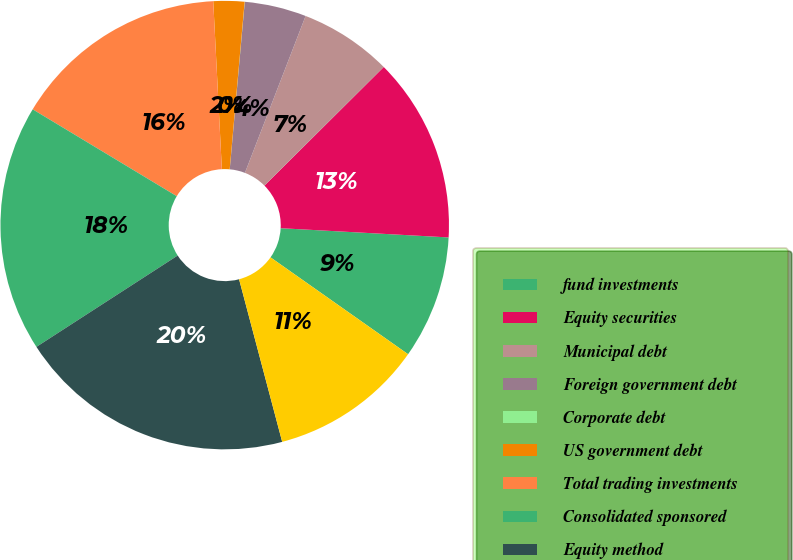Convert chart to OTSL. <chart><loc_0><loc_0><loc_500><loc_500><pie_chart><fcel>fund investments<fcel>Equity securities<fcel>Municipal debt<fcel>Foreign government debt<fcel>Corporate debt<fcel>US government debt<fcel>Total trading investments<fcel>Consolidated sponsored<fcel>Equity method<fcel>Deferred compensation plan<nl><fcel>8.89%<fcel>13.33%<fcel>6.67%<fcel>4.45%<fcel>0.01%<fcel>2.23%<fcel>15.55%<fcel>17.77%<fcel>19.99%<fcel>11.11%<nl></chart> 